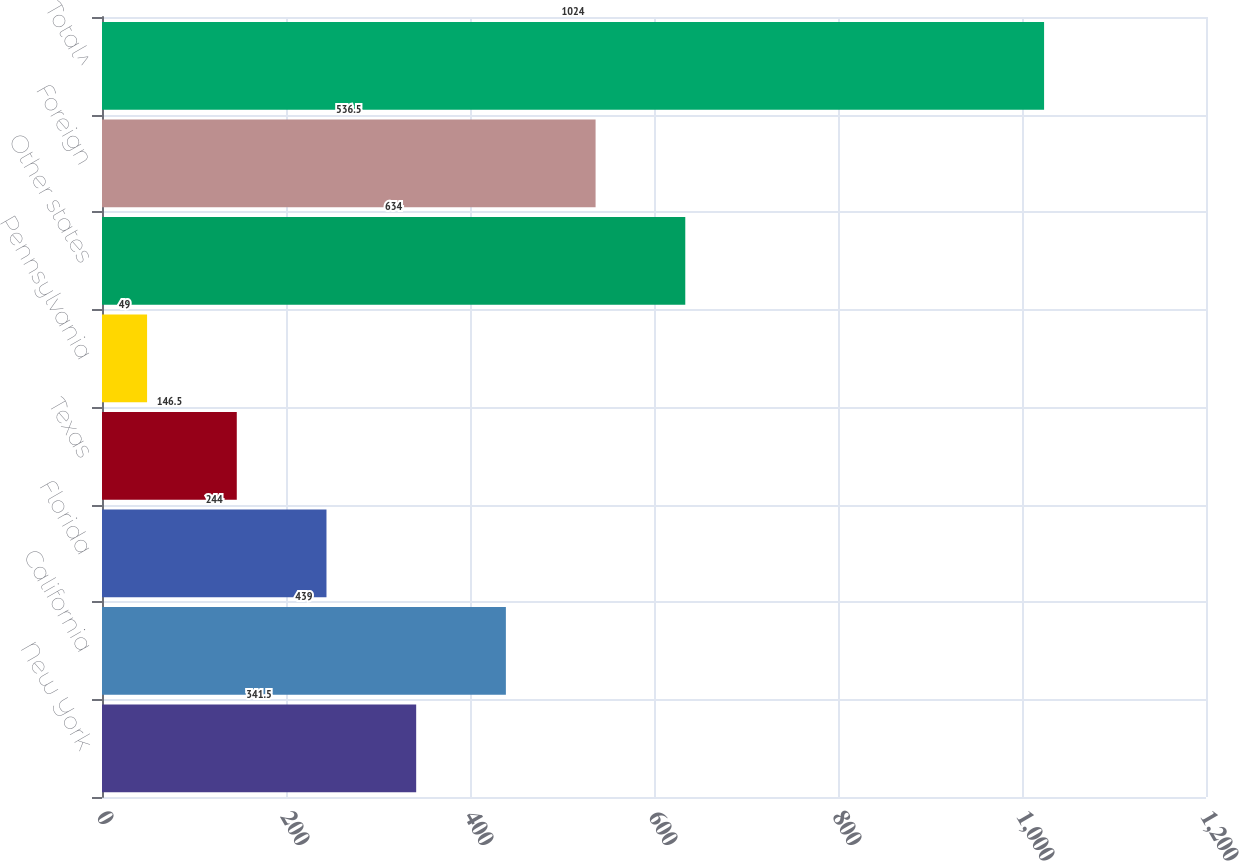<chart> <loc_0><loc_0><loc_500><loc_500><bar_chart><fcel>New York<fcel>California<fcel>Florida<fcel>Texas<fcel>Pennsylvania<fcel>Other states<fcel>Foreign<fcel>Total^<nl><fcel>341.5<fcel>439<fcel>244<fcel>146.5<fcel>49<fcel>634<fcel>536.5<fcel>1024<nl></chart> 